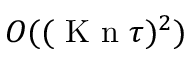Convert formula to latex. <formula><loc_0><loc_0><loc_500><loc_500>O ( ( { K n } \tau ) ^ { 2 } )</formula> 